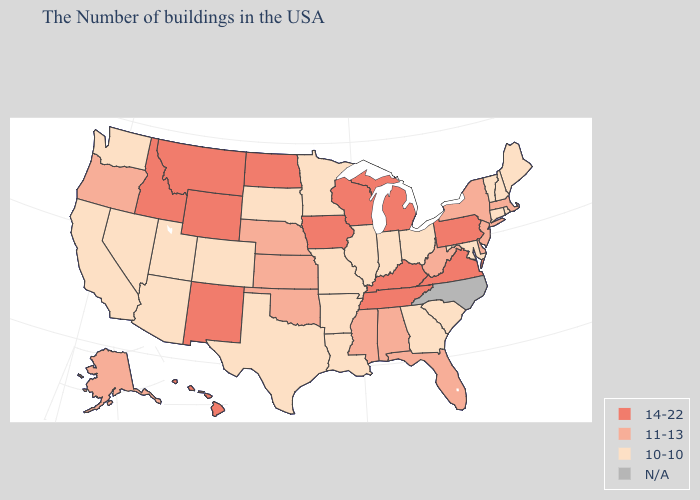What is the lowest value in states that border Nevada?
Concise answer only. 10-10. What is the highest value in the USA?
Short answer required. 14-22. Does Mississippi have the highest value in the USA?
Quick response, please. No. Name the states that have a value in the range 14-22?
Short answer required. Pennsylvania, Virginia, Michigan, Kentucky, Tennessee, Wisconsin, Iowa, North Dakota, Wyoming, New Mexico, Montana, Idaho, Hawaii. What is the highest value in the USA?
Keep it brief. 14-22. Among the states that border Wisconsin , which have the lowest value?
Keep it brief. Illinois, Minnesota. What is the highest value in the USA?
Keep it brief. 14-22. Is the legend a continuous bar?
Write a very short answer. No. What is the highest value in the USA?
Quick response, please. 14-22. What is the value of Mississippi?
Concise answer only. 11-13. Which states have the lowest value in the West?
Keep it brief. Colorado, Utah, Arizona, Nevada, California, Washington. Name the states that have a value in the range 11-13?
Write a very short answer. Massachusetts, New York, New Jersey, Delaware, West Virginia, Florida, Alabama, Mississippi, Kansas, Nebraska, Oklahoma, Oregon, Alaska. 